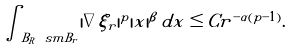<formula> <loc_0><loc_0><loc_500><loc_500>\int _ { B _ { R } \ s m B _ { r } } | \nabla \xi _ { r } | ^ { p } | x | ^ { \beta } \, d x \leq C r ^ { - \alpha ( p - 1 ) } .</formula> 